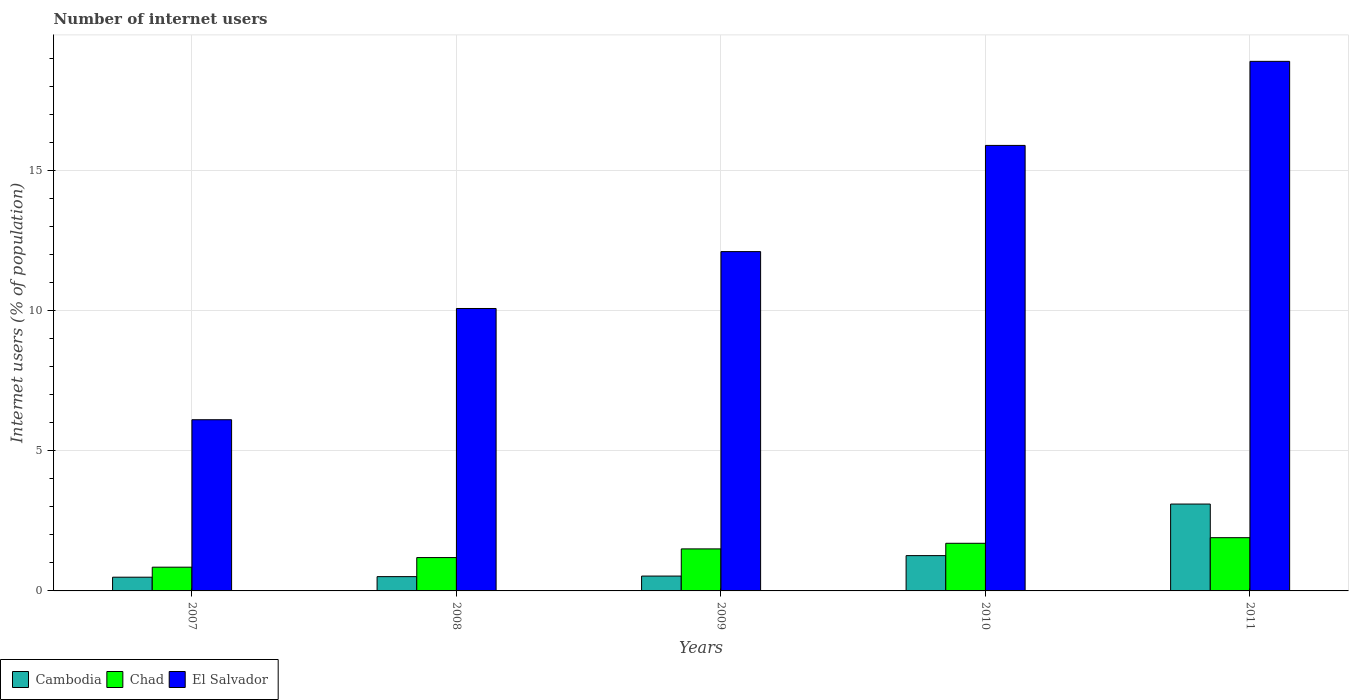How many different coloured bars are there?
Your response must be concise. 3. What is the number of internet users in Cambodia in 2009?
Your answer should be compact. 0.53. Across all years, what is the maximum number of internet users in Cambodia?
Provide a short and direct response. 3.1. Across all years, what is the minimum number of internet users in El Salvador?
Offer a terse response. 6.11. In which year was the number of internet users in El Salvador maximum?
Your answer should be compact. 2011. In which year was the number of internet users in Chad minimum?
Your response must be concise. 2007. What is the total number of internet users in Chad in the graph?
Your response must be concise. 7.14. What is the difference between the number of internet users in Cambodia in 2009 and that in 2010?
Your answer should be compact. -0.73. What is the difference between the number of internet users in El Salvador in 2007 and the number of internet users in Cambodia in 2009?
Make the answer very short. 5.58. What is the average number of internet users in Cambodia per year?
Keep it short and to the point. 1.18. In the year 2007, what is the difference between the number of internet users in El Salvador and number of internet users in Chad?
Your answer should be very brief. 5.26. In how many years, is the number of internet users in Chad greater than 1 %?
Make the answer very short. 4. What is the ratio of the number of internet users in Cambodia in 2009 to that in 2010?
Ensure brevity in your answer.  0.42. Is the number of internet users in Cambodia in 2009 less than that in 2010?
Your answer should be compact. Yes. Is the difference between the number of internet users in El Salvador in 2008 and 2010 greater than the difference between the number of internet users in Chad in 2008 and 2010?
Your answer should be very brief. No. What is the difference between the highest and the second highest number of internet users in El Salvador?
Provide a short and direct response. 3. What is the difference between the highest and the lowest number of internet users in Cambodia?
Offer a very short reply. 2.61. What does the 1st bar from the left in 2011 represents?
Keep it short and to the point. Cambodia. What does the 2nd bar from the right in 2011 represents?
Make the answer very short. Chad. Is it the case that in every year, the sum of the number of internet users in Chad and number of internet users in El Salvador is greater than the number of internet users in Cambodia?
Provide a short and direct response. Yes. How many bars are there?
Provide a short and direct response. 15. Are all the bars in the graph horizontal?
Offer a very short reply. No. How many years are there in the graph?
Keep it short and to the point. 5. What is the difference between two consecutive major ticks on the Y-axis?
Keep it short and to the point. 5. Are the values on the major ticks of Y-axis written in scientific E-notation?
Offer a very short reply. No. Does the graph contain grids?
Your answer should be very brief. Yes. Where does the legend appear in the graph?
Give a very brief answer. Bottom left. What is the title of the graph?
Your answer should be very brief. Number of internet users. What is the label or title of the X-axis?
Offer a very short reply. Years. What is the label or title of the Y-axis?
Provide a succinct answer. Internet users (% of population). What is the Internet users (% of population) in Cambodia in 2007?
Your response must be concise. 0.49. What is the Internet users (% of population) of Chad in 2007?
Offer a terse response. 0.85. What is the Internet users (% of population) in El Salvador in 2007?
Ensure brevity in your answer.  6.11. What is the Internet users (% of population) of Cambodia in 2008?
Your response must be concise. 0.51. What is the Internet users (% of population) of Chad in 2008?
Your answer should be very brief. 1.19. What is the Internet users (% of population) in El Salvador in 2008?
Your answer should be compact. 10.08. What is the Internet users (% of population) of Cambodia in 2009?
Give a very brief answer. 0.53. What is the Internet users (% of population) in Chad in 2009?
Make the answer very short. 1.5. What is the Internet users (% of population) in El Salvador in 2009?
Make the answer very short. 12.11. What is the Internet users (% of population) in Cambodia in 2010?
Give a very brief answer. 1.26. What is the Internet users (% of population) in Chad in 2011?
Ensure brevity in your answer.  1.9. What is the Internet users (% of population) of El Salvador in 2011?
Provide a short and direct response. 18.9. Across all years, what is the maximum Internet users (% of population) in Chad?
Provide a succinct answer. 1.9. Across all years, what is the maximum Internet users (% of population) in El Salvador?
Your response must be concise. 18.9. Across all years, what is the minimum Internet users (% of population) in Cambodia?
Ensure brevity in your answer.  0.49. Across all years, what is the minimum Internet users (% of population) in Chad?
Offer a terse response. 0.85. Across all years, what is the minimum Internet users (% of population) in El Salvador?
Offer a very short reply. 6.11. What is the total Internet users (% of population) of Cambodia in the graph?
Your answer should be very brief. 5.89. What is the total Internet users (% of population) of Chad in the graph?
Your answer should be very brief. 7.14. What is the total Internet users (% of population) in El Salvador in the graph?
Make the answer very short. 63.1. What is the difference between the Internet users (% of population) of Cambodia in 2007 and that in 2008?
Give a very brief answer. -0.02. What is the difference between the Internet users (% of population) in Chad in 2007 and that in 2008?
Give a very brief answer. -0.34. What is the difference between the Internet users (% of population) in El Salvador in 2007 and that in 2008?
Provide a succinct answer. -3.97. What is the difference between the Internet users (% of population) in Cambodia in 2007 and that in 2009?
Ensure brevity in your answer.  -0.04. What is the difference between the Internet users (% of population) in Chad in 2007 and that in 2009?
Your answer should be compact. -0.65. What is the difference between the Internet users (% of population) in Cambodia in 2007 and that in 2010?
Keep it short and to the point. -0.77. What is the difference between the Internet users (% of population) in Chad in 2007 and that in 2010?
Give a very brief answer. -0.85. What is the difference between the Internet users (% of population) in El Salvador in 2007 and that in 2010?
Your response must be concise. -9.79. What is the difference between the Internet users (% of population) in Cambodia in 2007 and that in 2011?
Keep it short and to the point. -2.61. What is the difference between the Internet users (% of population) in Chad in 2007 and that in 2011?
Offer a terse response. -1.05. What is the difference between the Internet users (% of population) in El Salvador in 2007 and that in 2011?
Ensure brevity in your answer.  -12.79. What is the difference between the Internet users (% of population) in Cambodia in 2008 and that in 2009?
Give a very brief answer. -0.02. What is the difference between the Internet users (% of population) in Chad in 2008 and that in 2009?
Keep it short and to the point. -0.31. What is the difference between the Internet users (% of population) in El Salvador in 2008 and that in 2009?
Provide a succinct answer. -2.03. What is the difference between the Internet users (% of population) in Cambodia in 2008 and that in 2010?
Provide a succinct answer. -0.75. What is the difference between the Internet users (% of population) of Chad in 2008 and that in 2010?
Your answer should be very brief. -0.51. What is the difference between the Internet users (% of population) of El Salvador in 2008 and that in 2010?
Provide a short and direct response. -5.82. What is the difference between the Internet users (% of population) in Cambodia in 2008 and that in 2011?
Your answer should be very brief. -2.59. What is the difference between the Internet users (% of population) in Chad in 2008 and that in 2011?
Keep it short and to the point. -0.71. What is the difference between the Internet users (% of population) in El Salvador in 2008 and that in 2011?
Offer a terse response. -8.82. What is the difference between the Internet users (% of population) in Cambodia in 2009 and that in 2010?
Provide a succinct answer. -0.73. What is the difference between the Internet users (% of population) of El Salvador in 2009 and that in 2010?
Your answer should be very brief. -3.79. What is the difference between the Internet users (% of population) of Cambodia in 2009 and that in 2011?
Your response must be concise. -2.57. What is the difference between the Internet users (% of population) of El Salvador in 2009 and that in 2011?
Offer a terse response. -6.79. What is the difference between the Internet users (% of population) in Cambodia in 2010 and that in 2011?
Keep it short and to the point. -1.84. What is the difference between the Internet users (% of population) of Chad in 2010 and that in 2011?
Provide a succinct answer. -0.2. What is the difference between the Internet users (% of population) in Cambodia in 2007 and the Internet users (% of population) in Chad in 2008?
Provide a succinct answer. -0.7. What is the difference between the Internet users (% of population) in Cambodia in 2007 and the Internet users (% of population) in El Salvador in 2008?
Keep it short and to the point. -9.59. What is the difference between the Internet users (% of population) in Chad in 2007 and the Internet users (% of population) in El Salvador in 2008?
Offer a very short reply. -9.23. What is the difference between the Internet users (% of population) in Cambodia in 2007 and the Internet users (% of population) in Chad in 2009?
Keep it short and to the point. -1.01. What is the difference between the Internet users (% of population) in Cambodia in 2007 and the Internet users (% of population) in El Salvador in 2009?
Provide a succinct answer. -11.62. What is the difference between the Internet users (% of population) in Chad in 2007 and the Internet users (% of population) in El Salvador in 2009?
Your answer should be very brief. -11.26. What is the difference between the Internet users (% of population) in Cambodia in 2007 and the Internet users (% of population) in Chad in 2010?
Keep it short and to the point. -1.21. What is the difference between the Internet users (% of population) in Cambodia in 2007 and the Internet users (% of population) in El Salvador in 2010?
Your answer should be compact. -15.41. What is the difference between the Internet users (% of population) of Chad in 2007 and the Internet users (% of population) of El Salvador in 2010?
Your response must be concise. -15.05. What is the difference between the Internet users (% of population) of Cambodia in 2007 and the Internet users (% of population) of Chad in 2011?
Provide a short and direct response. -1.41. What is the difference between the Internet users (% of population) of Cambodia in 2007 and the Internet users (% of population) of El Salvador in 2011?
Provide a succinct answer. -18.41. What is the difference between the Internet users (% of population) of Chad in 2007 and the Internet users (% of population) of El Salvador in 2011?
Make the answer very short. -18.05. What is the difference between the Internet users (% of population) of Cambodia in 2008 and the Internet users (% of population) of Chad in 2009?
Provide a short and direct response. -0.99. What is the difference between the Internet users (% of population) of Chad in 2008 and the Internet users (% of population) of El Salvador in 2009?
Ensure brevity in your answer.  -10.92. What is the difference between the Internet users (% of population) in Cambodia in 2008 and the Internet users (% of population) in Chad in 2010?
Your answer should be compact. -1.19. What is the difference between the Internet users (% of population) in Cambodia in 2008 and the Internet users (% of population) in El Salvador in 2010?
Give a very brief answer. -15.39. What is the difference between the Internet users (% of population) in Chad in 2008 and the Internet users (% of population) in El Salvador in 2010?
Ensure brevity in your answer.  -14.71. What is the difference between the Internet users (% of population) of Cambodia in 2008 and the Internet users (% of population) of Chad in 2011?
Make the answer very short. -1.39. What is the difference between the Internet users (% of population) in Cambodia in 2008 and the Internet users (% of population) in El Salvador in 2011?
Your answer should be very brief. -18.39. What is the difference between the Internet users (% of population) in Chad in 2008 and the Internet users (% of population) in El Salvador in 2011?
Ensure brevity in your answer.  -17.71. What is the difference between the Internet users (% of population) of Cambodia in 2009 and the Internet users (% of population) of Chad in 2010?
Your response must be concise. -1.17. What is the difference between the Internet users (% of population) of Cambodia in 2009 and the Internet users (% of population) of El Salvador in 2010?
Your response must be concise. -15.37. What is the difference between the Internet users (% of population) in Chad in 2009 and the Internet users (% of population) in El Salvador in 2010?
Offer a terse response. -14.4. What is the difference between the Internet users (% of population) in Cambodia in 2009 and the Internet users (% of population) in Chad in 2011?
Keep it short and to the point. -1.37. What is the difference between the Internet users (% of population) in Cambodia in 2009 and the Internet users (% of population) in El Salvador in 2011?
Your response must be concise. -18.37. What is the difference between the Internet users (% of population) in Chad in 2009 and the Internet users (% of population) in El Salvador in 2011?
Your answer should be very brief. -17.4. What is the difference between the Internet users (% of population) in Cambodia in 2010 and the Internet users (% of population) in Chad in 2011?
Offer a terse response. -0.64. What is the difference between the Internet users (% of population) in Cambodia in 2010 and the Internet users (% of population) in El Salvador in 2011?
Your answer should be compact. -17.64. What is the difference between the Internet users (% of population) of Chad in 2010 and the Internet users (% of population) of El Salvador in 2011?
Your response must be concise. -17.2. What is the average Internet users (% of population) in Cambodia per year?
Your answer should be compact. 1.18. What is the average Internet users (% of population) in Chad per year?
Your answer should be compact. 1.43. What is the average Internet users (% of population) of El Salvador per year?
Keep it short and to the point. 12.62. In the year 2007, what is the difference between the Internet users (% of population) of Cambodia and Internet users (% of population) of Chad?
Offer a terse response. -0.36. In the year 2007, what is the difference between the Internet users (% of population) of Cambodia and Internet users (% of population) of El Salvador?
Provide a short and direct response. -5.62. In the year 2007, what is the difference between the Internet users (% of population) of Chad and Internet users (% of population) of El Salvador?
Your response must be concise. -5.26. In the year 2008, what is the difference between the Internet users (% of population) of Cambodia and Internet users (% of population) of Chad?
Your answer should be compact. -0.68. In the year 2008, what is the difference between the Internet users (% of population) in Cambodia and Internet users (% of population) in El Salvador?
Offer a very short reply. -9.57. In the year 2008, what is the difference between the Internet users (% of population) in Chad and Internet users (% of population) in El Salvador?
Your response must be concise. -8.89. In the year 2009, what is the difference between the Internet users (% of population) in Cambodia and Internet users (% of population) in Chad?
Ensure brevity in your answer.  -0.97. In the year 2009, what is the difference between the Internet users (% of population) of Cambodia and Internet users (% of population) of El Salvador?
Your answer should be compact. -11.58. In the year 2009, what is the difference between the Internet users (% of population) of Chad and Internet users (% of population) of El Salvador?
Make the answer very short. -10.61. In the year 2010, what is the difference between the Internet users (% of population) of Cambodia and Internet users (% of population) of Chad?
Provide a short and direct response. -0.44. In the year 2010, what is the difference between the Internet users (% of population) in Cambodia and Internet users (% of population) in El Salvador?
Provide a short and direct response. -14.64. In the year 2010, what is the difference between the Internet users (% of population) in Chad and Internet users (% of population) in El Salvador?
Your answer should be very brief. -14.2. In the year 2011, what is the difference between the Internet users (% of population) in Cambodia and Internet users (% of population) in El Salvador?
Provide a succinct answer. -15.8. What is the ratio of the Internet users (% of population) of Cambodia in 2007 to that in 2008?
Provide a short and direct response. 0.96. What is the ratio of the Internet users (% of population) in Chad in 2007 to that in 2008?
Your answer should be very brief. 0.71. What is the ratio of the Internet users (% of population) of El Salvador in 2007 to that in 2008?
Provide a short and direct response. 0.61. What is the ratio of the Internet users (% of population) of Cambodia in 2007 to that in 2009?
Make the answer very short. 0.92. What is the ratio of the Internet users (% of population) of Chad in 2007 to that in 2009?
Ensure brevity in your answer.  0.56. What is the ratio of the Internet users (% of population) in El Salvador in 2007 to that in 2009?
Provide a succinct answer. 0.5. What is the ratio of the Internet users (% of population) of Cambodia in 2007 to that in 2010?
Ensure brevity in your answer.  0.39. What is the ratio of the Internet users (% of population) in Chad in 2007 to that in 2010?
Make the answer very short. 0.5. What is the ratio of the Internet users (% of population) in El Salvador in 2007 to that in 2010?
Offer a terse response. 0.38. What is the ratio of the Internet users (% of population) in Cambodia in 2007 to that in 2011?
Your response must be concise. 0.16. What is the ratio of the Internet users (% of population) in Chad in 2007 to that in 2011?
Offer a very short reply. 0.45. What is the ratio of the Internet users (% of population) of El Salvador in 2007 to that in 2011?
Keep it short and to the point. 0.32. What is the ratio of the Internet users (% of population) in Cambodia in 2008 to that in 2009?
Your response must be concise. 0.96. What is the ratio of the Internet users (% of population) in Chad in 2008 to that in 2009?
Make the answer very short. 0.79. What is the ratio of the Internet users (% of population) of El Salvador in 2008 to that in 2009?
Your answer should be compact. 0.83. What is the ratio of the Internet users (% of population) in Cambodia in 2008 to that in 2010?
Provide a succinct answer. 0.4. What is the ratio of the Internet users (% of population) in El Salvador in 2008 to that in 2010?
Give a very brief answer. 0.63. What is the ratio of the Internet users (% of population) in Cambodia in 2008 to that in 2011?
Your response must be concise. 0.16. What is the ratio of the Internet users (% of population) in Chad in 2008 to that in 2011?
Make the answer very short. 0.63. What is the ratio of the Internet users (% of population) of El Salvador in 2008 to that in 2011?
Offer a very short reply. 0.53. What is the ratio of the Internet users (% of population) in Cambodia in 2009 to that in 2010?
Offer a very short reply. 0.42. What is the ratio of the Internet users (% of population) of Chad in 2009 to that in 2010?
Ensure brevity in your answer.  0.88. What is the ratio of the Internet users (% of population) in El Salvador in 2009 to that in 2010?
Give a very brief answer. 0.76. What is the ratio of the Internet users (% of population) of Cambodia in 2009 to that in 2011?
Offer a very short reply. 0.17. What is the ratio of the Internet users (% of population) of Chad in 2009 to that in 2011?
Ensure brevity in your answer.  0.79. What is the ratio of the Internet users (% of population) of El Salvador in 2009 to that in 2011?
Provide a succinct answer. 0.64. What is the ratio of the Internet users (% of population) in Cambodia in 2010 to that in 2011?
Your answer should be very brief. 0.41. What is the ratio of the Internet users (% of population) in Chad in 2010 to that in 2011?
Provide a short and direct response. 0.89. What is the ratio of the Internet users (% of population) in El Salvador in 2010 to that in 2011?
Keep it short and to the point. 0.84. What is the difference between the highest and the second highest Internet users (% of population) in Cambodia?
Offer a very short reply. 1.84. What is the difference between the highest and the second highest Internet users (% of population) of El Salvador?
Your answer should be compact. 3. What is the difference between the highest and the lowest Internet users (% of population) of Cambodia?
Make the answer very short. 2.61. What is the difference between the highest and the lowest Internet users (% of population) of Chad?
Provide a short and direct response. 1.05. What is the difference between the highest and the lowest Internet users (% of population) in El Salvador?
Ensure brevity in your answer.  12.79. 